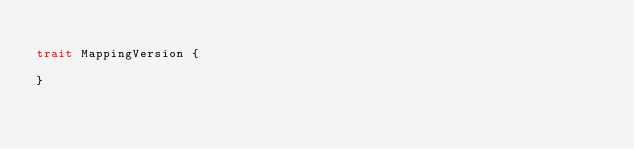Convert code to text. <code><loc_0><loc_0><loc_500><loc_500><_Scala_>
trait MappingVersion {
  
}
</code> 